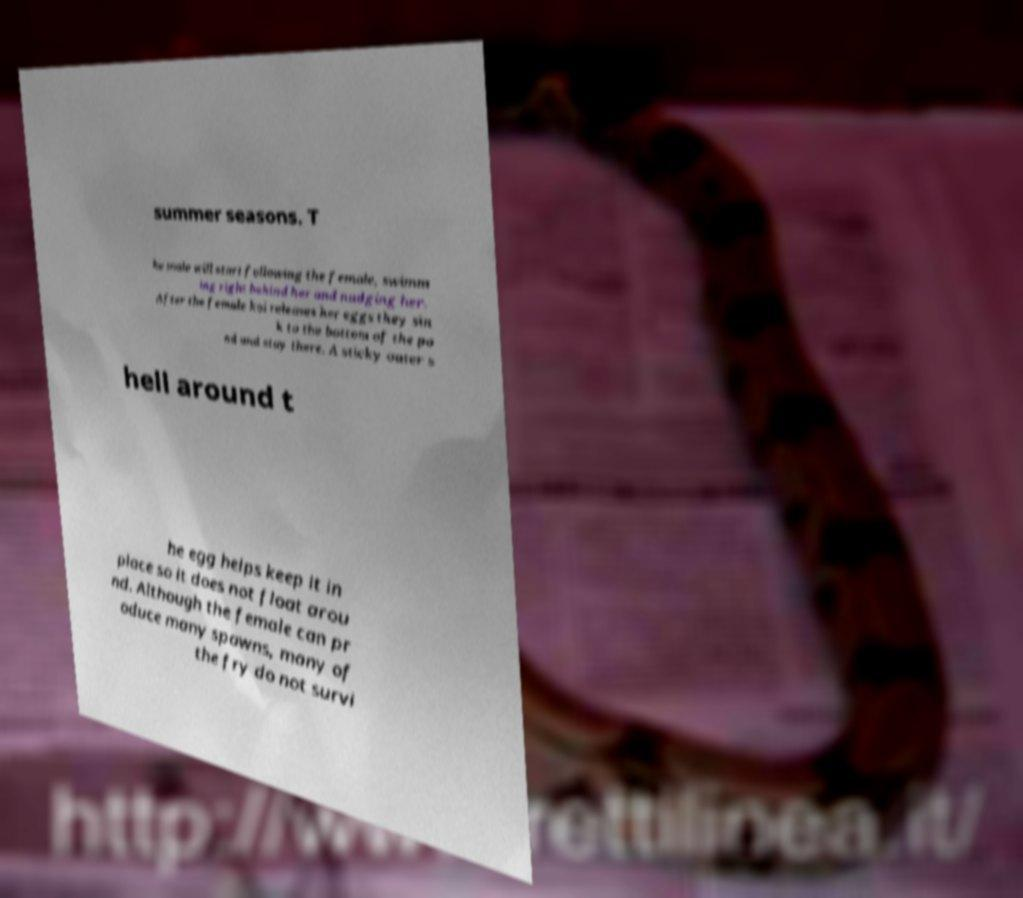Can you read and provide the text displayed in the image?This photo seems to have some interesting text. Can you extract and type it out for me? summer seasons. T he male will start following the female, swimm ing right behind her and nudging her. After the female koi releases her eggs they sin k to the bottom of the po nd and stay there. A sticky outer s hell around t he egg helps keep it in place so it does not float arou nd. Although the female can pr oduce many spawns, many of the fry do not survi 